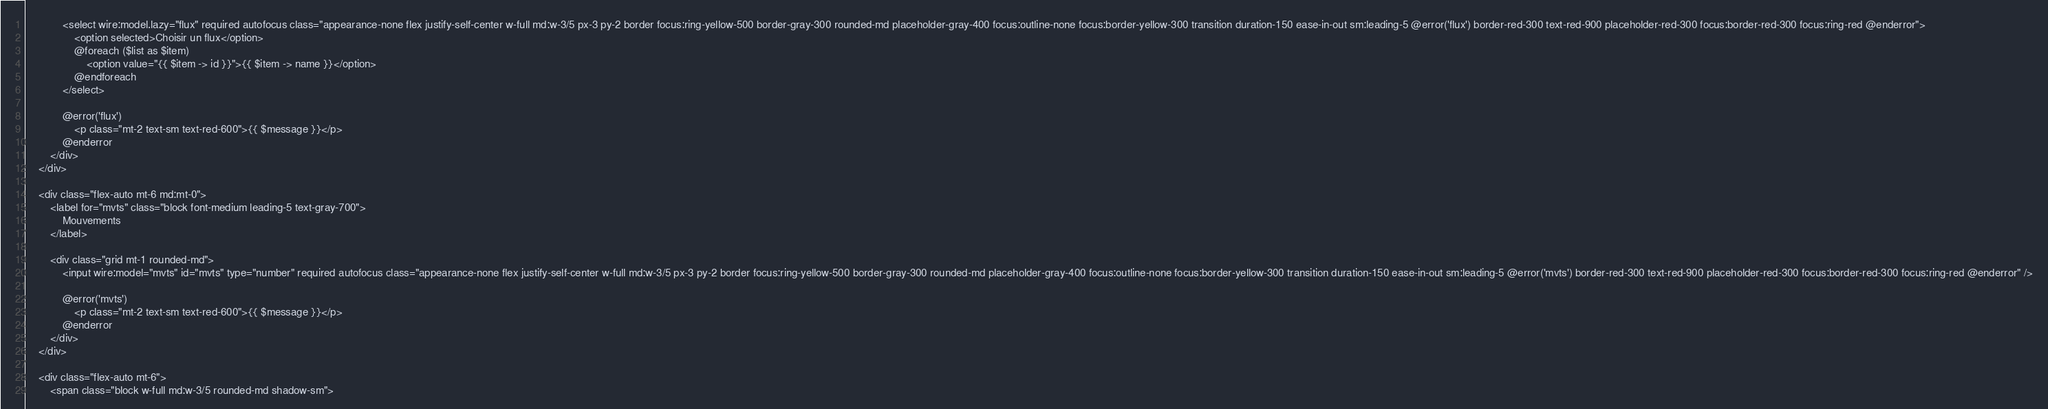Convert code to text. <code><loc_0><loc_0><loc_500><loc_500><_PHP_>            <select wire:model.lazy="flux" required autofocus class="appearance-none flex justify-self-center w-full md:w-3/5 px-3 py-2 border focus:ring-yellow-500 border-gray-300 rounded-md placeholder-gray-400 focus:outline-none focus:border-yellow-300 transition duration-150 ease-in-out sm:leading-5 @error('flux') border-red-300 text-red-900 placeholder-red-300 focus:border-red-300 focus:ring-red @enderror">
                <option selected>Choisir un flux</option>
                @foreach ($list as $item)
                    <option value="{{ $item -> id }}">{{ $item -> name }}</option>
                @endforeach
            </select>

            @error('flux')
                <p class="mt-2 text-sm text-red-600">{{ $message }}</p>
            @enderror
        </div>
    </div>

    <div class="flex-auto mt-6 md:mt-0">
        <label for="mvts" class="block font-medium leading-5 text-gray-700">
            Mouvements
        </label>

        <div class="grid mt-1 rounded-md">
            <input wire:model="mvts" id="mvts" type="number" required autofocus class="appearance-none flex justify-self-center w-full md:w-3/5 px-3 py-2 border focus:ring-yellow-500 border-gray-300 rounded-md placeholder-gray-400 focus:outline-none focus:border-yellow-300 transition duration-150 ease-in-out sm:leading-5 @error('mvts') border-red-300 text-red-900 placeholder-red-300 focus:border-red-300 focus:ring-red @enderror" />

            @error('mvts')
                <p class="mt-2 text-sm text-red-600">{{ $message }}</p>
            @enderror
        </div>
    </div>

    <div class="flex-auto mt-6">
        <span class="block w-full md:w-3/5 rounded-md shadow-sm"></code> 